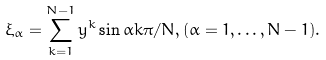Convert formula to latex. <formula><loc_0><loc_0><loc_500><loc_500>\xi _ { \alpha } = \sum _ { k = 1 } ^ { N - 1 } y ^ { k } \sin \alpha k \pi / N , ( \alpha = 1 , \dots , N - 1 ) .</formula> 